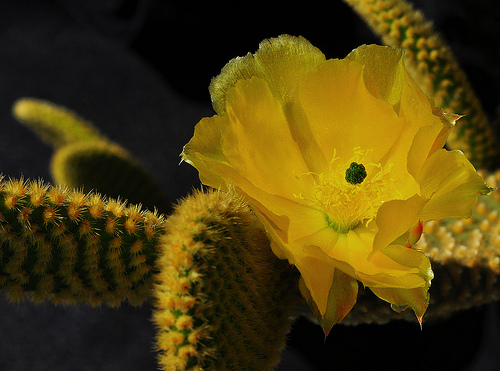<image>
Can you confirm if the flower is next to the cactus? No. The flower is not positioned next to the cactus. They are located in different areas of the scene. 